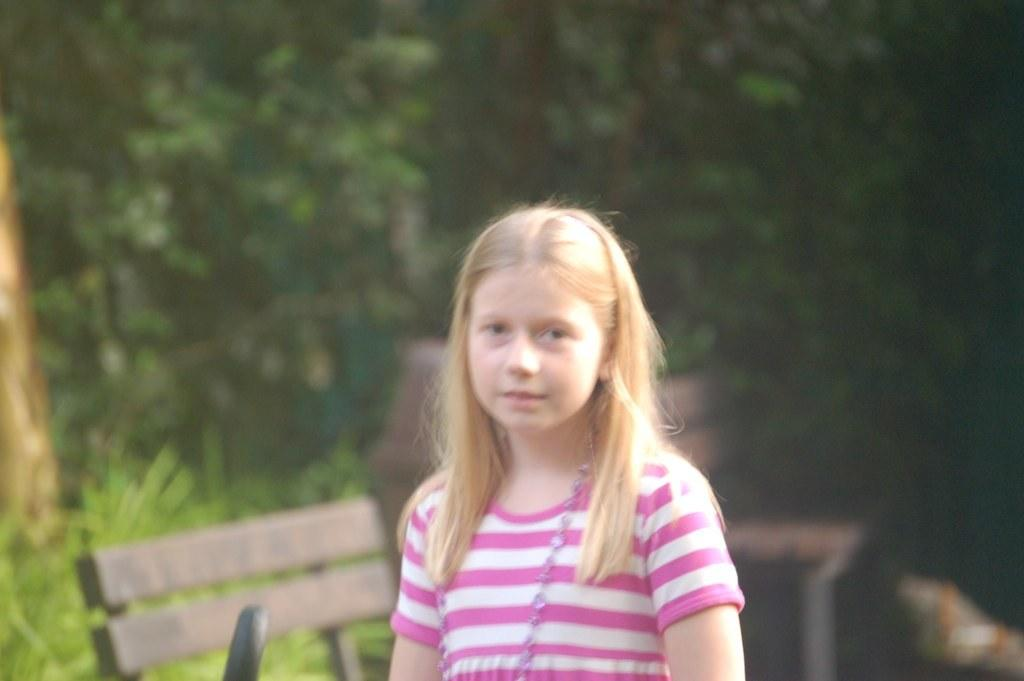Who or what is the main subject in the image? There is a person in the image. What is the person wearing? The person is wearing a pink and white dress. What can be seen in the background of the image? There are benches and trees with green color in the background of the image. Where is the desk located in the image? There is no desk present in the image. What type of hill can be seen in the background of the image? There is no hill visible in the image; only trees and benches are present in the background. 